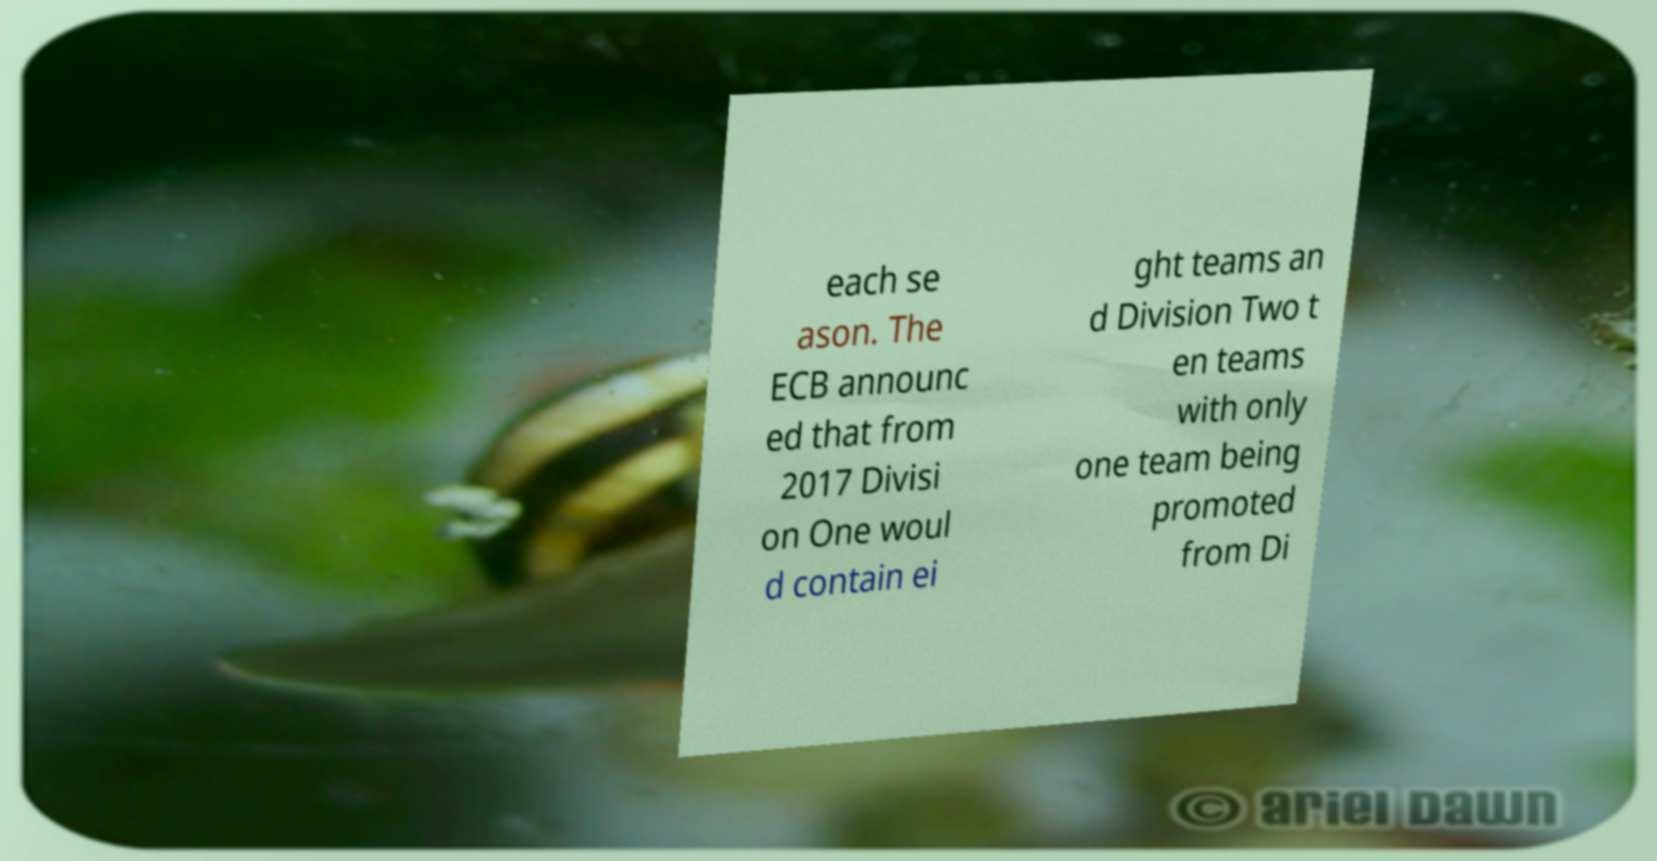Could you extract and type out the text from this image? each se ason. The ECB announc ed that from 2017 Divisi on One woul d contain ei ght teams an d Division Two t en teams with only one team being promoted from Di 